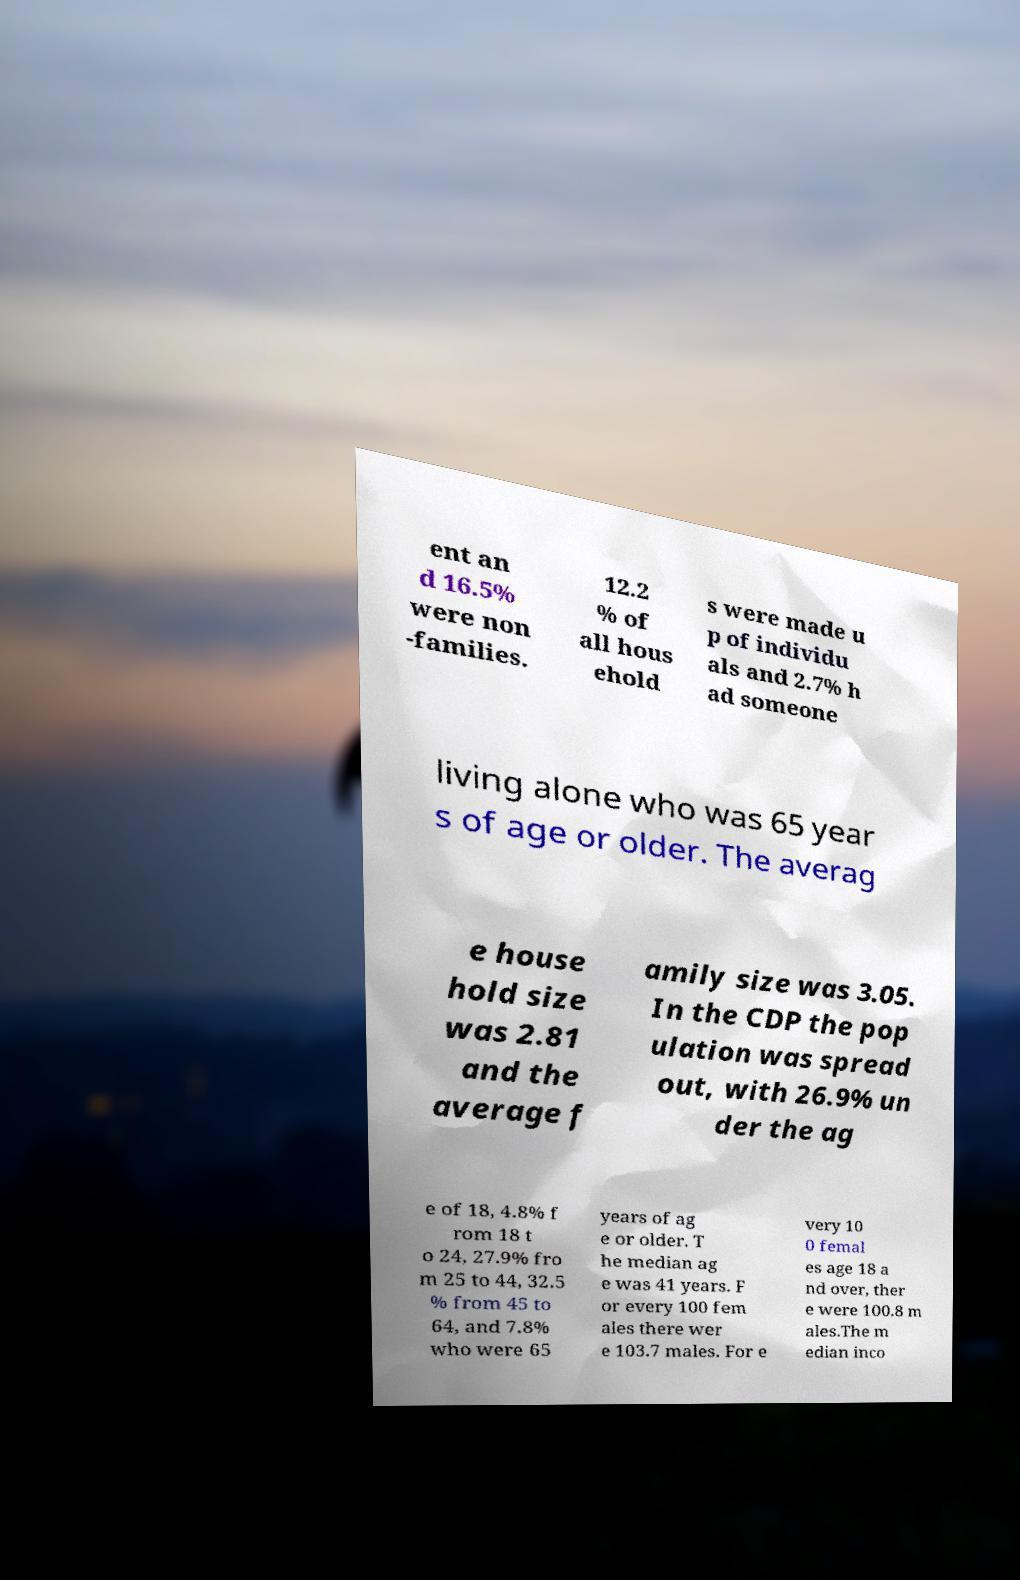What messages or text are displayed in this image? I need them in a readable, typed format. ent an d 16.5% were non -families. 12.2 % of all hous ehold s were made u p of individu als and 2.7% h ad someone living alone who was 65 year s of age or older. The averag e house hold size was 2.81 and the average f amily size was 3.05. In the CDP the pop ulation was spread out, with 26.9% un der the ag e of 18, 4.8% f rom 18 t o 24, 27.9% fro m 25 to 44, 32.5 % from 45 to 64, and 7.8% who were 65 years of ag e or older. T he median ag e was 41 years. F or every 100 fem ales there wer e 103.7 males. For e very 10 0 femal es age 18 a nd over, ther e were 100.8 m ales.The m edian inco 